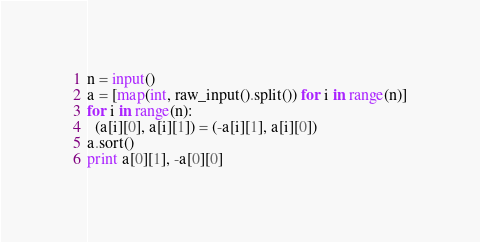Convert code to text. <code><loc_0><loc_0><loc_500><loc_500><_Python_>n = input()
a = [map(int, raw_input().split()) for i in range(n)]
for i in range(n):
  (a[i][0], a[i][1]) = (-a[i][1], a[i][0])
a.sort()
print a[0][1], -a[0][0]</code> 